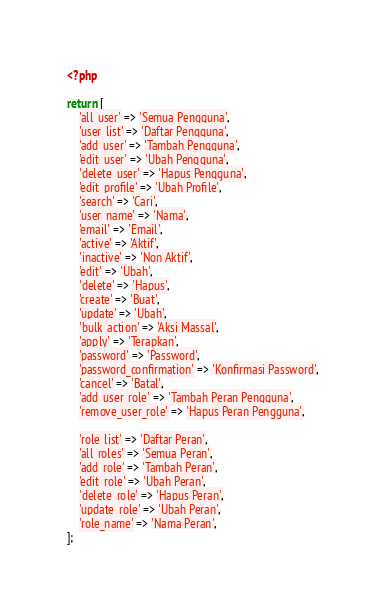Convert code to text. <code><loc_0><loc_0><loc_500><loc_500><_PHP_><?php

return [
    'all_user' => 'Semua Pengguna',
    'user_list' => 'Daftar Pengguna',
    'add_user' => 'Tambah Pengguna',
    'edit_user' => 'Ubah Pengguna',
    'delete_user' => 'Hapus Pengguna',
    'edit_profile' => 'Ubah Profile',
    'search' => 'Cari',
    'user_name' => 'Nama',
    'email' => 'Email',
    'active' => 'Aktif',
    'inactive' => 'Non Aktif',
    'edit' => 'Ubah',
    'delete' => 'Hapus',
    'create' => 'Buat',
    'update' => 'Ubah',
    'bulk_action' => 'Aksi Massal',
    'apply' => 'Terapkan',
    'password' => 'Password',
    'password_confirmation' => 'Konfirmasi Password',
    'cancel' => 'Batal',
    'add_user_role' => 'Tambah Peran Pengguna',
    'remove_user_role' => 'Hapus Peran Pengguna',

    'role_list' => 'Daftar Peran',
    'all_roles' => 'Semua Peran',
    'add_role' => 'Tambah Peran',
    'edit_role' => 'Ubah Peran',
    'delete_role' => 'Hapus Peran',
    'update_role' => 'Ubah Peran',
    'role_name' => 'Nama Peran',
];
</code> 